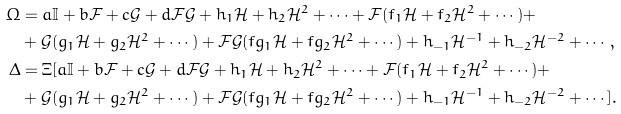Convert formula to latex. <formula><loc_0><loc_0><loc_500><loc_500>\Omega & = a \mathbb { I } + b \mathcal { F } + c \mathcal { G } + d \mathcal { F G } + h _ { 1 } \mathcal { H } + h _ { 2 } \mathcal { H } ^ { 2 } + \cdots + \mathcal { F } ( f _ { 1 } \mathcal { H } + f _ { 2 } \mathcal { H } ^ { 2 } + \cdots ) + \\ & + \mathcal { G } ( g _ { 1 } \mathcal { H } + g _ { 2 } \mathcal { H } ^ { 2 } + \cdots ) + \mathcal { F G } ( f g _ { 1 } \mathcal { H } + f g _ { 2 } \mathcal { H } ^ { 2 } + \cdots ) + h _ { - 1 } \mathcal { H } ^ { - 1 } + h _ { - 2 } \mathcal { H } ^ { - 2 } + \cdots , \\ \Delta & = \Xi [ a \mathbb { I } + b \mathcal { F } + c \mathcal { G } + d \mathcal { F G } + h _ { 1 } \mathcal { H } + h _ { 2 } \mathcal { H } ^ { 2 } + \cdots + \mathcal { F } ( f _ { 1 } \mathcal { H } + f _ { 2 } \mathcal { H } ^ { 2 } + \cdots ) + \\ & + \mathcal { G } ( g _ { 1 } \mathcal { H } + g _ { 2 } \mathcal { H } ^ { 2 } + \cdots ) + \mathcal { F G } ( f g _ { 1 } \mathcal { H } + f g _ { 2 } \mathcal { H } ^ { 2 } + \cdots ) + h _ { - 1 } \mathcal { H } ^ { - 1 } + h _ { - 2 } \mathcal { H } ^ { - 2 } + \cdots ] .</formula> 